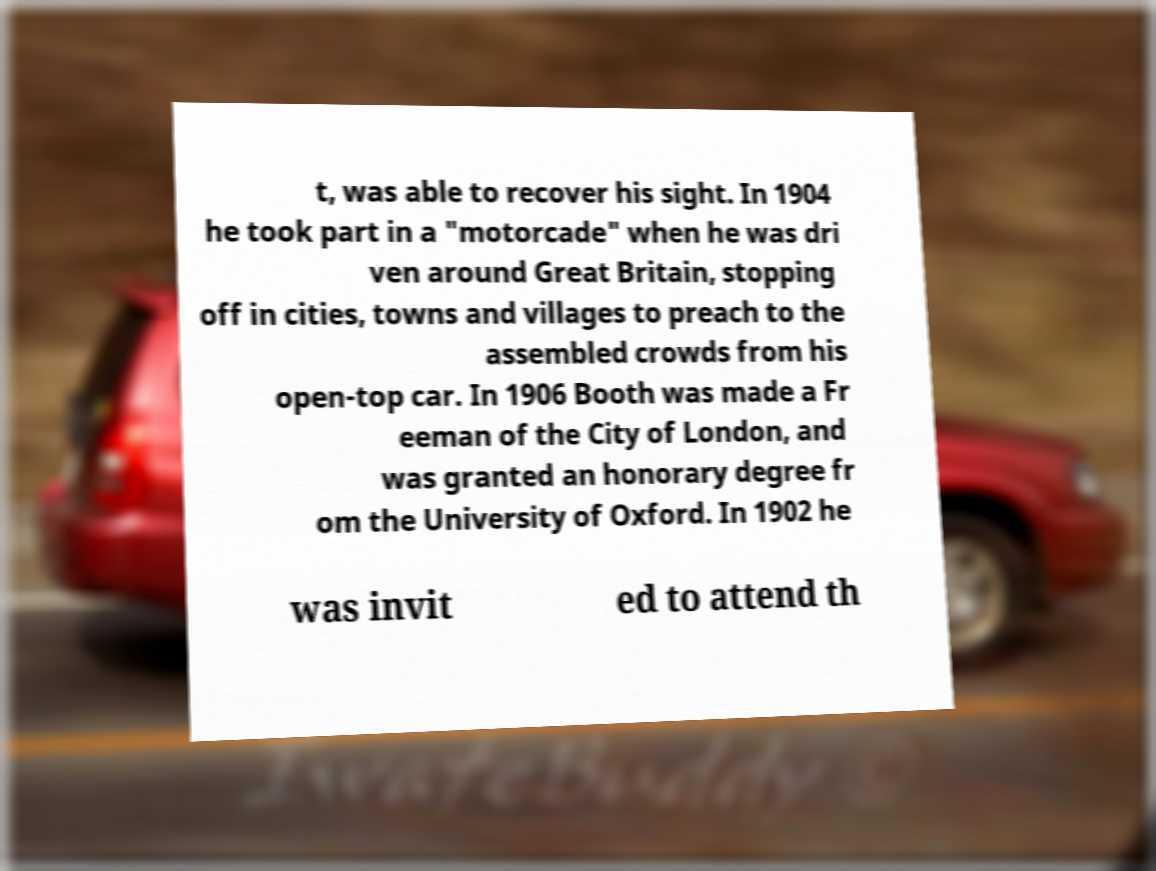Could you assist in decoding the text presented in this image and type it out clearly? t, was able to recover his sight. In 1904 he took part in a "motorcade" when he was dri ven around Great Britain, stopping off in cities, towns and villages to preach to the assembled crowds from his open-top car. In 1906 Booth was made a Fr eeman of the City of London, and was granted an honorary degree fr om the University of Oxford. In 1902 he was invit ed to attend th 